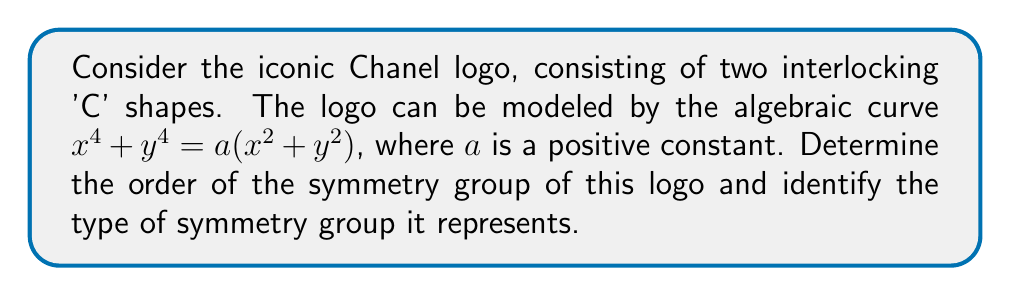Provide a solution to this math problem. Let's approach this step-by-step:

1) First, we need to understand the symmetries of the Chanel logo:
   a) Rotation symmetry: The logo remains unchanged when rotated by 90°, 180°, 270°, and 360°.
   b) Reflection symmetry: The logo has four lines of reflection (horizontal, vertical, and two diagonals).

2) To confirm these symmetries algebraically, we can examine the equation $x^4 + y^4 = a(x^2 + y^2)$:
   a) Rotating by 90° is equivalent to the transformation $(x, y) \rightarrow (-y, x)$. Substituting this into the equation:
      $(-y)^4 + x^4 = a((-y)^2 + x^2)$
      $y^4 + x^4 = a(y^2 + x^2)$
      This is the same as the original equation, confirming 90° rotation symmetry.
   
   b) Reflecting across the y-axis is equivalent to $(x, y) \rightarrow (-x, y)$. Substituting:
      $(-x)^4 + y^4 = a((-x)^2 + y^2)$
      $x^4 + y^4 = a(x^2 + y^2)$
      Again, this is the same as the original equation, confirming reflection symmetry.

3) The symmetries we've identified form a group under composition. This group includes:
   - 4 rotations (0°, 90°, 180°, 270°)
   - 4 reflections (horizontal, vertical, two diagonals)

4) The total number of symmetries (order of the group) is 8.

5) This symmetry group is isomorphic to the dihedral group $D_4$, which is the symmetry group of a square.
Answer: Order: 8; Group type: $D_4$ (Dihedral group of order 8) 